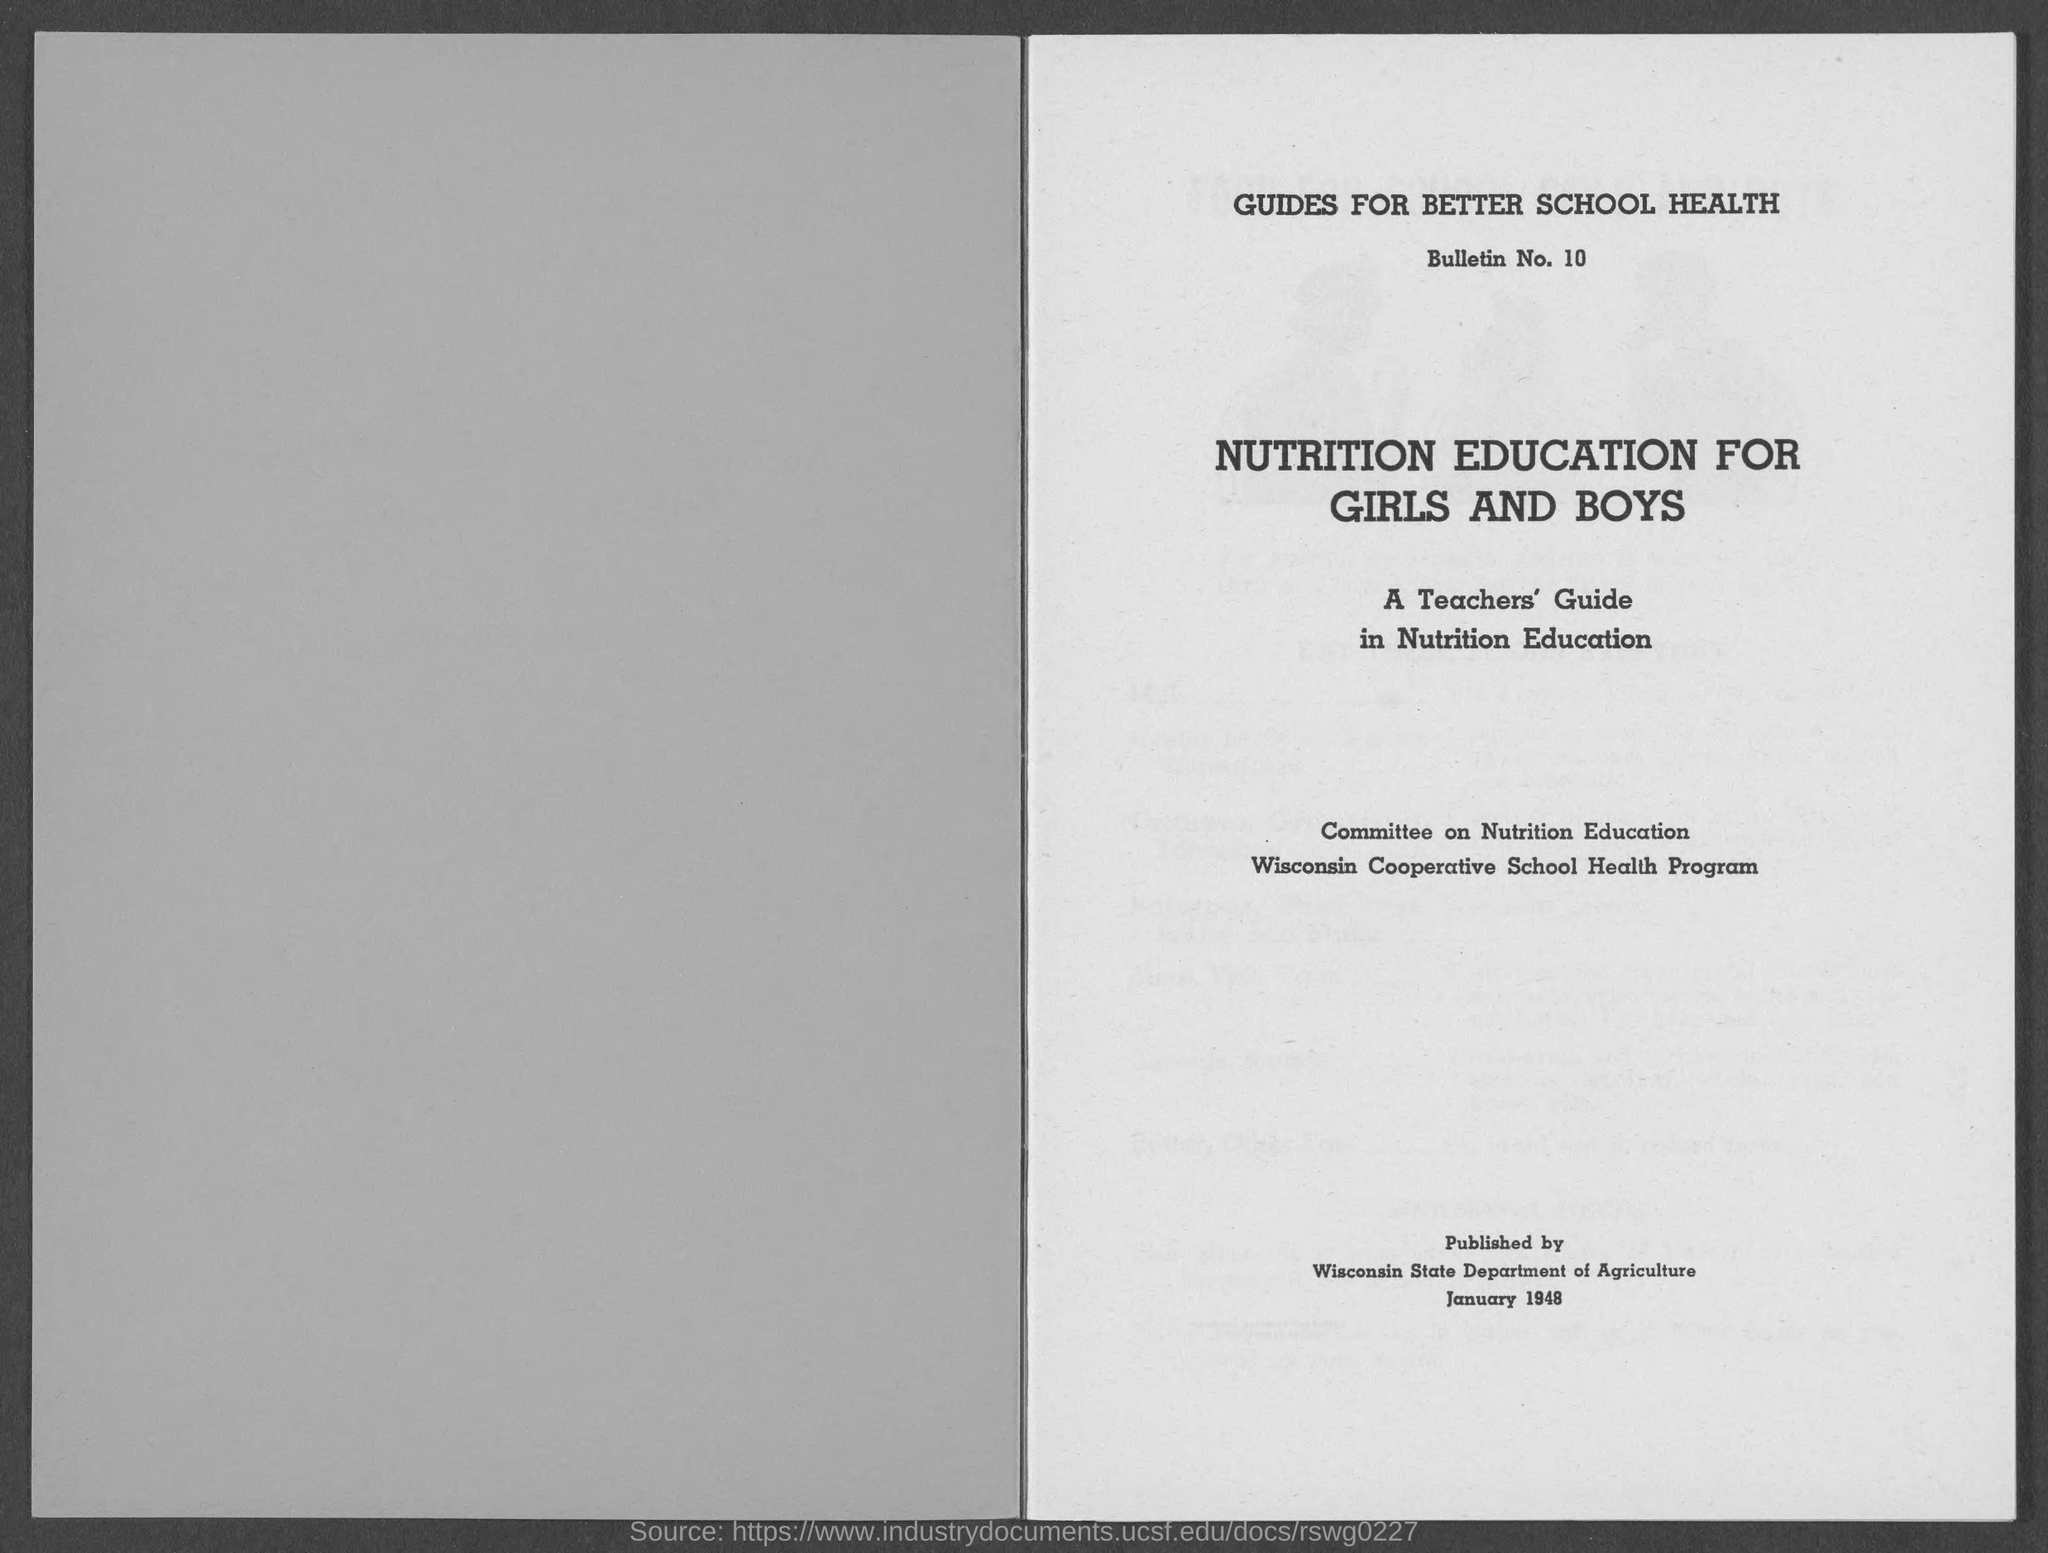Identify some key points in this picture. The date of publication is January 1948. The bulletin number is 10. 